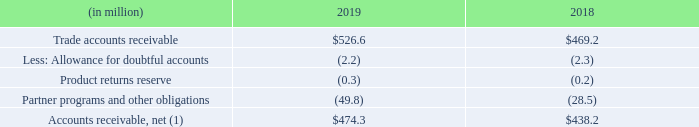Accounts Receivable, Net
Accounts receivable, net, consisted of the following as of January 31:
(1) Autodesk adopted ASU No. 2014-09, “Revenue from Contracts with Customers" regarding Accounting Standards Codification (ASC Topic 606) during the first quarter of fiscal 2019. As such, current year balances are shown under ASC Topic 606 and prior year balances are shown under ASC Topic 605. See Note 1, "Business and Summary of Significant Accounting Policies-Accounting Standards Adopted", of our consolidated financial statements for additional information.
Allowances for uncollectible trade receivables are based upon historical loss patterns, the number of days that billings are past due, and an evaluation of the potential risk of loss associated with problem accounts.
As part of the indirect channel model, Autodesk has a partner incentive program that uses quarterly attainment of monetary rewards to motivate distributors and resellers to achieve mutually agreed upon business goals in a specified time period. A portion of these incentives reduce maintenance and other revenue in the current period. The remainder, which relates to incentives on our Subscription Program, is recorded as a reduction to deferred revenue in the period the subscription transaction is billed and subsequently recognized as a reduction to subscription revenue over the contract period. These incentive balances do not require significant assumptions or judgments. Depending on how the payments are made, the reserves associated with the partner incentive program are treated on the balance sheet as either contra accounts receivable or accounts payable
What are allowances for uncollectible trade receivables based on? Historical loss patterns, the number of days that billings are past due, and an evaluation of the potential risk of loss associated with problem accounts. What does Autodesk consider the monetary rewards given to partners as? Either contra accounts receivable or accounts payable. What was the amount of trade accounts receivable in 2018? $469.2. What are the total deductions for accounts receivables in 2019?
Answer scale should be: million. 526.6-474.3
Answer: 52.3. What is the difference in net accounts receivable from 2018 to 2019?
Answer scale should be: million. 474.3-438.2
Answer: 36.1. What is the average trade accounts receivable from 2018 to 2019?
Answer scale should be: million. (526.6+469.2)/2 
Answer: 497.9. 